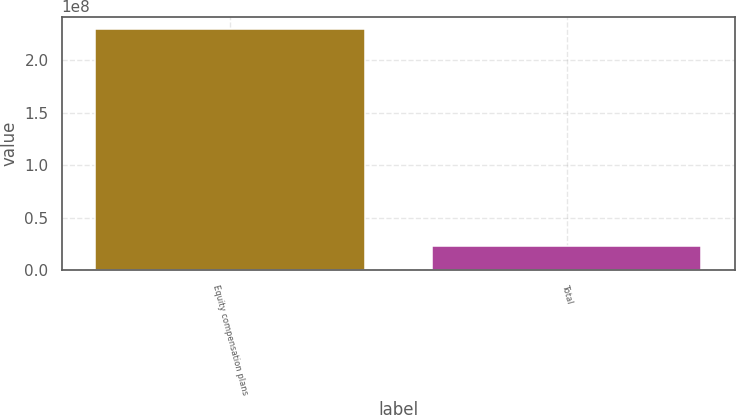Convert chart. <chart><loc_0><loc_0><loc_500><loc_500><bar_chart><fcel>Equity compensation plans<fcel>Total<nl><fcel>2.29964e+08<fcel>2.29964e+07<nl></chart> 